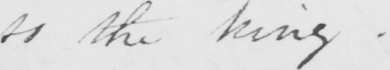Can you tell me what this handwritten text says? to the king . 